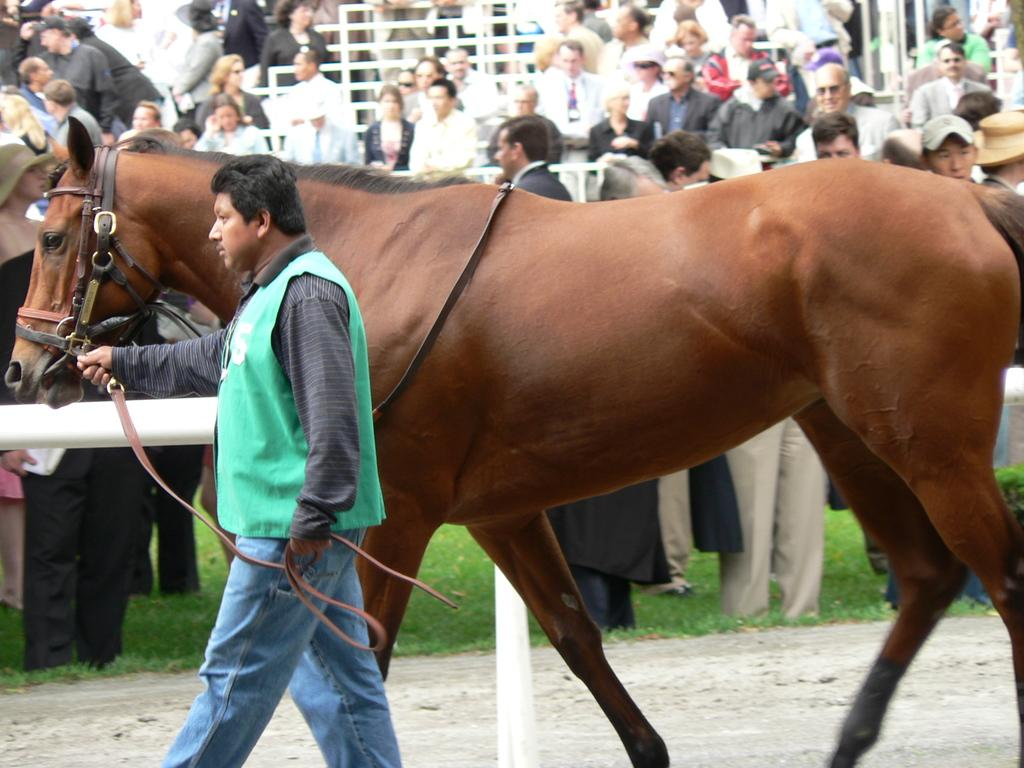What is the main subject of the image? The main subject of the image is a man. What is the man wearing? The man is wearing a jacket. What is the man doing in the image? The man is holding a horse with a rope. What can be seen in the background of the image? There is a crowd of people and a fence in the background of the image. What type of terrain is visible in the image? Grass and land are visible in the image. What type of brake can be seen on the horse in the image? There is no brake present on the horse in the image. What color is the rose that the man is holding in the image? There is no rose present in the image; the man is holding a horse with a rope. 